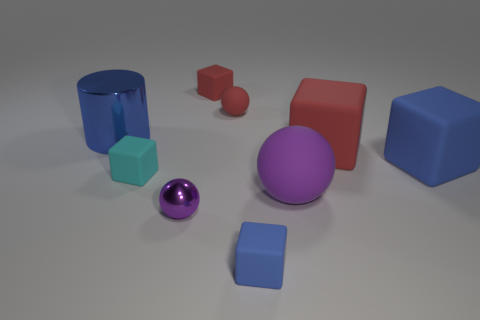How many yellow objects are either shiny things or small cubes?
Keep it short and to the point. 0. What size is the blue metallic thing?
Keep it short and to the point. Large. Are there more small rubber objects in front of the small metallic ball than big cylinders?
Offer a terse response. No. How many cyan things are behind the large blue cylinder?
Make the answer very short. 0. Are there any other cylinders that have the same size as the shiny cylinder?
Keep it short and to the point. No. What is the color of the big rubber thing that is the same shape as the small purple metallic thing?
Your response must be concise. Purple. Do the blue block that is to the left of the large rubber ball and the red block that is in front of the blue cylinder have the same size?
Your answer should be very brief. No. Are there any large yellow shiny things that have the same shape as the purple rubber object?
Make the answer very short. No. Are there the same number of tiny blue objects that are in front of the large red cube and big matte cubes?
Offer a terse response. No. There is a cyan matte thing; does it have the same size as the ball behind the big metallic thing?
Provide a short and direct response. Yes. 